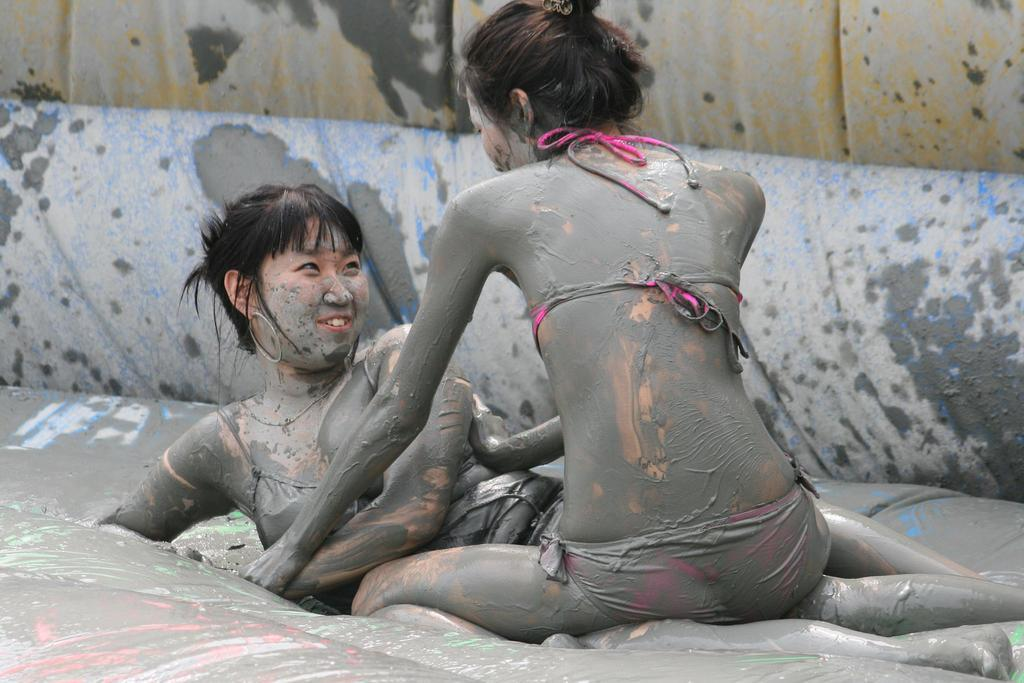How many people are in the image? There are persons in the image. What are the persons in the image doing? The persons are playing in the mud. What type of crime is being committed in the image? There is no crime being committed in the image; the persons are simply playing in the mud. What sound does the bell make in the image? There is no bell present in the image. 